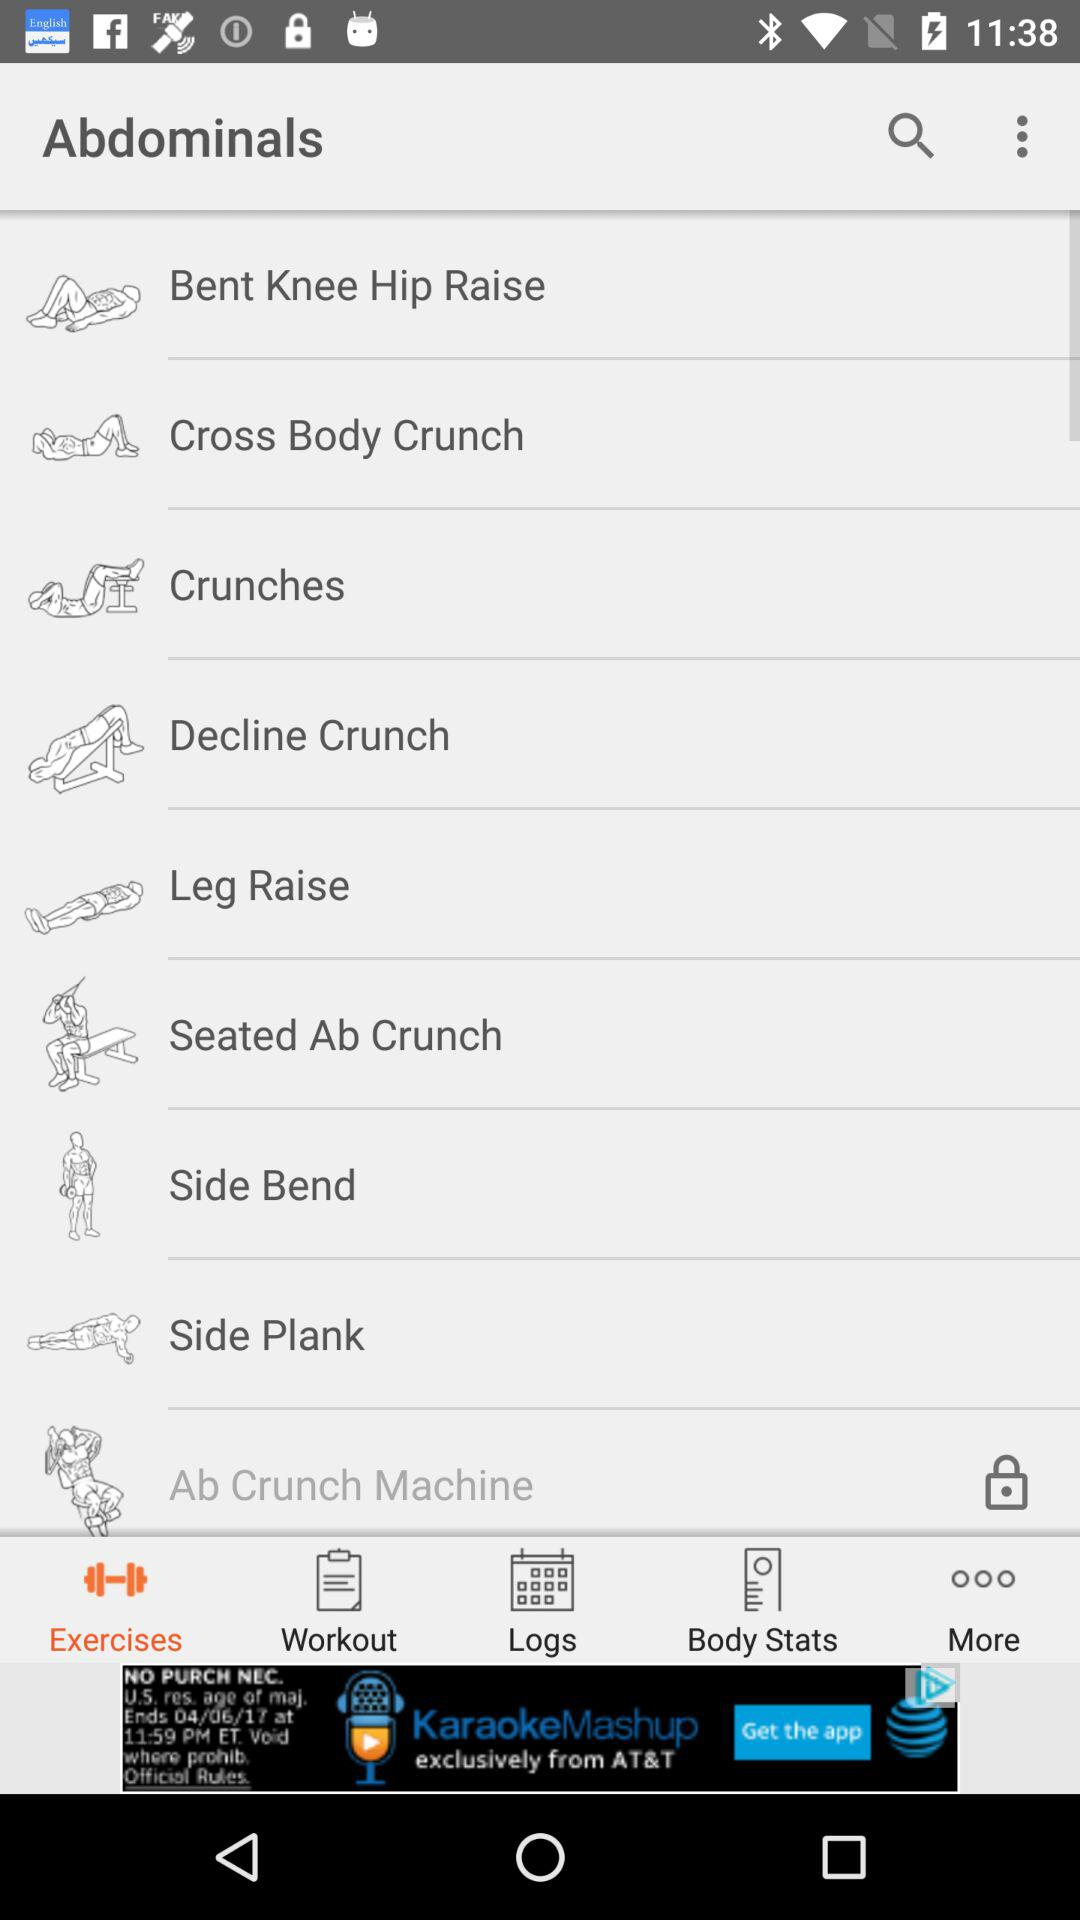What is the selected tab? The selected tab is "Exercises". 